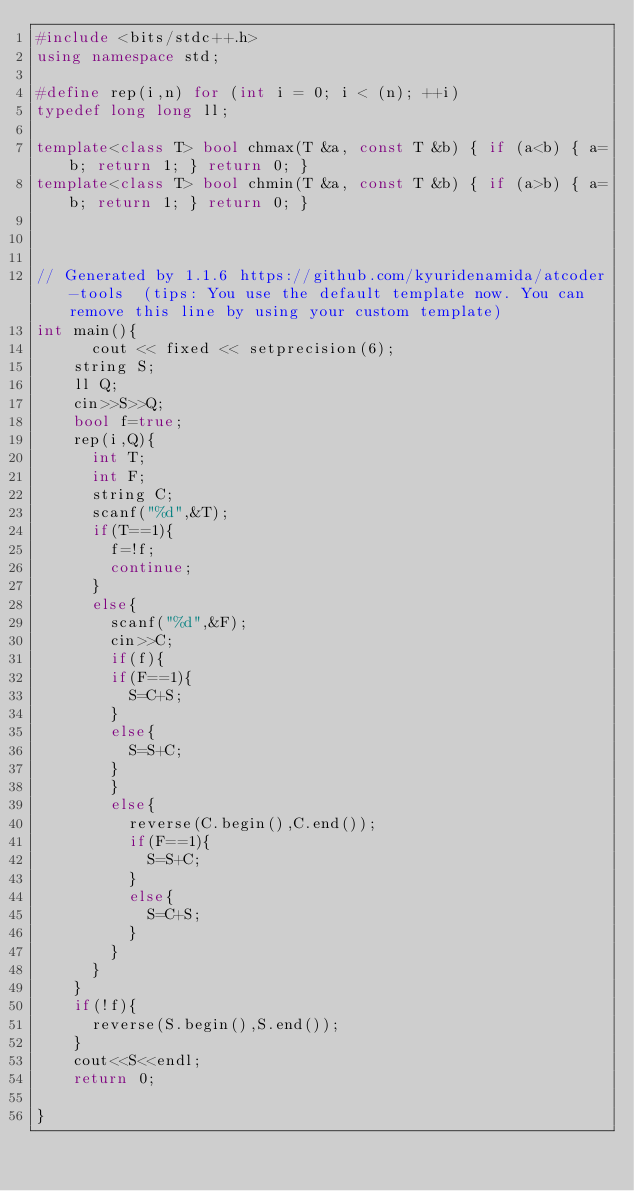Convert code to text. <code><loc_0><loc_0><loc_500><loc_500><_C++_>#include <bits/stdc++.h>
using namespace std;

#define rep(i,n) for (int i = 0; i < (n); ++i)
typedef long long ll;

template<class T> bool chmax(T &a, const T &b) { if (a<b) { a=b; return 1; } return 0; }
template<class T> bool chmin(T &a, const T &b) { if (a>b) { a=b; return 1; } return 0; }



// Generated by 1.1.6 https://github.com/kyuridenamida/atcoder-tools  (tips: You use the default template now. You can remove this line by using your custom template)
int main(){
      cout << fixed << setprecision(6);
    string S;
    ll Q;
    cin>>S>>Q;
    bool f=true;
    rep(i,Q){
      int T;
      int F;
      string C;
      scanf("%d",&T);
      if(T==1){
        f=!f;
        continue;
      }
      else{
        scanf("%d",&F);
        cin>>C;
        if(f){
        if(F==1){
          S=C+S;
        }
        else{
          S=S+C;
        }
        }
        else{
          reverse(C.begin(),C.end());
          if(F==1){
            S=S+C;
          }
          else{
            S=C+S;
          }
        }
      }
    }
    if(!f){
      reverse(S.begin(),S.end());
    }
    cout<<S<<endl;
    return 0;
    
}
</code> 